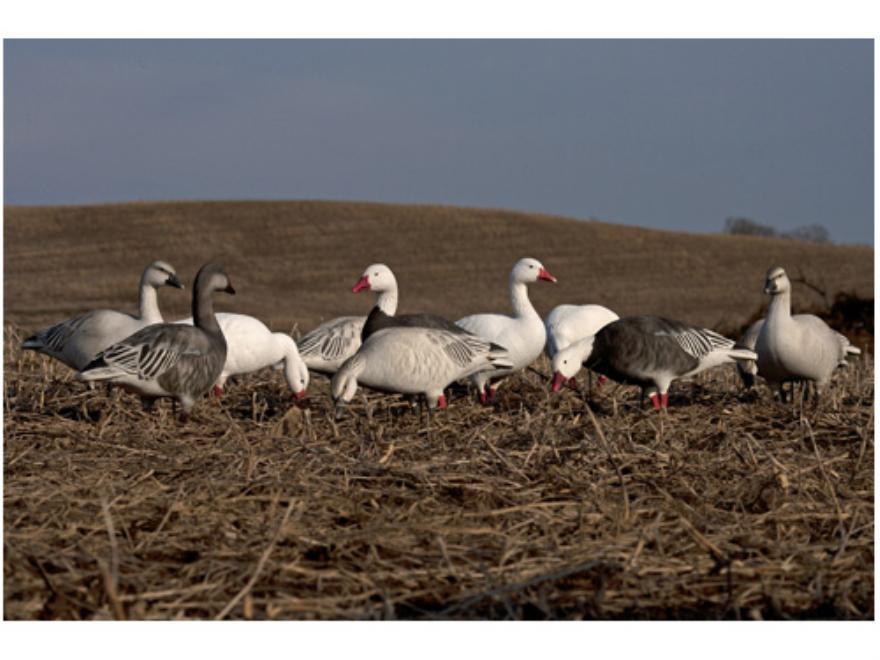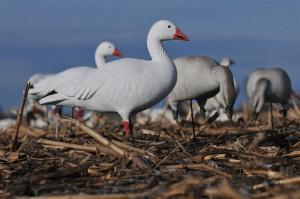The first image is the image on the left, the second image is the image on the right. For the images displayed, is the sentence "The left image includes a row of white and darker grayer duck decoys, and the right image features a white duck decoy closest to the camera." factually correct? Answer yes or no. Yes. The first image is the image on the left, the second image is the image on the right. Evaluate the accuracy of this statement regarding the images: "Two birds in the left image have dark bodies and white heads.". Is it true? Answer yes or no. Yes. 